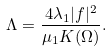<formula> <loc_0><loc_0><loc_500><loc_500>\Lambda = \frac { 4 \lambda _ { 1 } | f | ^ { 2 } } { \mu _ { 1 } K ( \Omega ) } .</formula> 